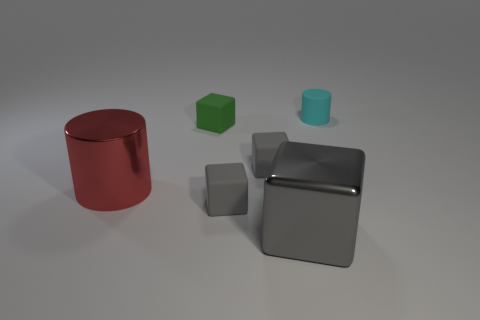There is a big metallic thing that is the same shape as the green rubber object; what is its color?
Offer a very short reply. Gray. Do the large block and the matte thing that is in front of the red metallic cylinder have the same color?
Your answer should be very brief. Yes. There is a green block; are there any metallic objects to the left of it?
Ensure brevity in your answer.  Yes. Are there any tiny gray matte blocks that are on the left side of the cylinder that is right of the big gray object?
Give a very brief answer. Yes. Are there an equal number of gray matte objects in front of the red cylinder and small matte cubes right of the tiny cyan rubber object?
Provide a short and direct response. No. The big cube that is the same material as the red cylinder is what color?
Keep it short and to the point. Gray. Is there a cube made of the same material as the large cylinder?
Keep it short and to the point. Yes. How many objects are either red cylinders or gray shiny blocks?
Provide a succinct answer. 2. Are the small cylinder and the big thing in front of the large cylinder made of the same material?
Your response must be concise. No. How big is the gray matte cube in front of the metal cylinder?
Give a very brief answer. Small. 